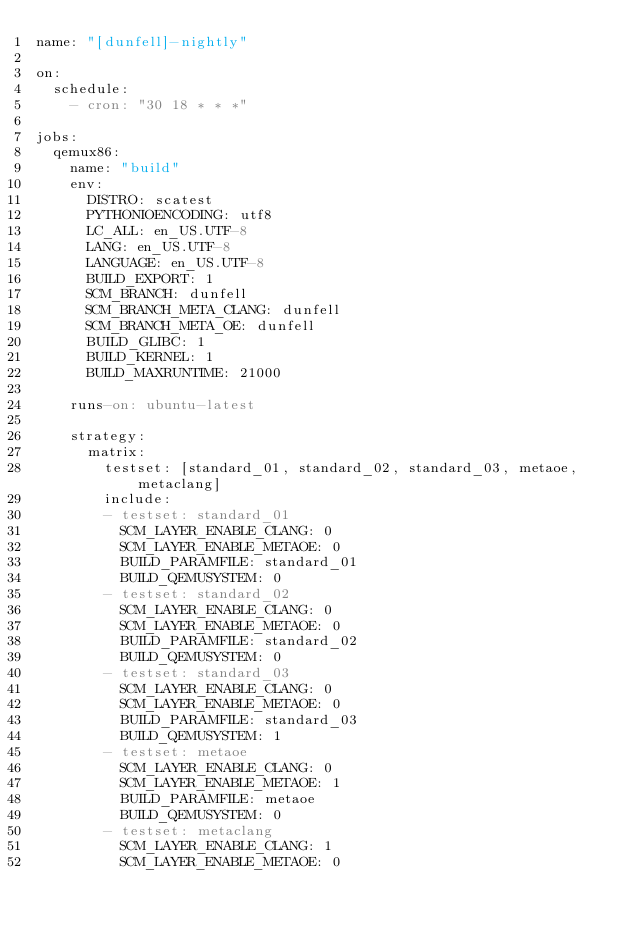Convert code to text. <code><loc_0><loc_0><loc_500><loc_500><_YAML_>name: "[dunfell]-nightly"

on:
  schedule:
    - cron: "30 18 * * *"

jobs:
  qemux86:
    name: "build"
    env:
      DISTRO: scatest
      PYTHONIOENCODING: utf8
      LC_ALL: en_US.UTF-8
      LANG: en_US.UTF-8
      LANGUAGE: en_US.UTF-8
      BUILD_EXPORT: 1
      SCM_BRANCH: dunfell
      SCM_BRANCH_META_CLANG: dunfell
      SCM_BRANCH_META_OE: dunfell
      BUILD_GLIBC: 1
      BUILD_KERNEL: 1
      BUILD_MAXRUNTIME: 21000

    runs-on: ubuntu-latest

    strategy:
      matrix:
        testset: [standard_01, standard_02, standard_03, metaoe, metaclang]
        include:
        - testset: standard_01
          SCM_LAYER_ENABLE_CLANG: 0
          SCM_LAYER_ENABLE_METAOE: 0
          BUILD_PARAMFILE: standard_01
          BUILD_QEMUSYSTEM: 0
        - testset: standard_02
          SCM_LAYER_ENABLE_CLANG: 0
          SCM_LAYER_ENABLE_METAOE: 0
          BUILD_PARAMFILE: standard_02
          BUILD_QEMUSYSTEM: 0
        - testset: standard_03
          SCM_LAYER_ENABLE_CLANG: 0
          SCM_LAYER_ENABLE_METAOE: 0
          BUILD_PARAMFILE: standard_03
          BUILD_QEMUSYSTEM: 1
        - testset: metaoe
          SCM_LAYER_ENABLE_CLANG: 0
          SCM_LAYER_ENABLE_METAOE: 1
          BUILD_PARAMFILE: metaoe
          BUILD_QEMUSYSTEM: 0
        - testset: metaclang
          SCM_LAYER_ENABLE_CLANG: 1
          SCM_LAYER_ENABLE_METAOE: 0</code> 